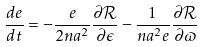Convert formula to latex. <formula><loc_0><loc_0><loc_500><loc_500>\frac { d e } { d t } = - \frac { e } { 2 n a ^ { 2 } } \frac { \partial \mathcal { R } } { \partial \epsilon } - \frac { 1 } { n a ^ { 2 } e } \frac { \partial \mathcal { R } } { \partial \varpi }</formula> 